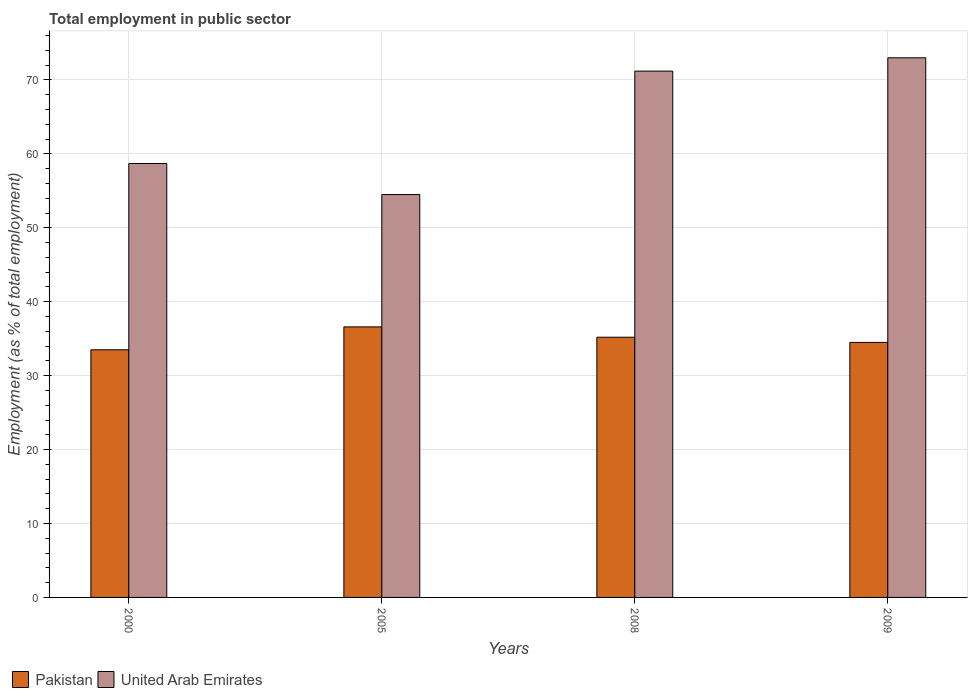Are the number of bars per tick equal to the number of legend labels?
Keep it short and to the point. Yes. Across all years, what is the maximum employment in public sector in United Arab Emirates?
Offer a terse response. 73. Across all years, what is the minimum employment in public sector in United Arab Emirates?
Ensure brevity in your answer.  54.5. What is the total employment in public sector in United Arab Emirates in the graph?
Your response must be concise. 257.4. What is the difference between the employment in public sector in Pakistan in 2000 and that in 2009?
Give a very brief answer. -1. What is the difference between the employment in public sector in Pakistan in 2000 and the employment in public sector in United Arab Emirates in 2005?
Give a very brief answer. -21. What is the average employment in public sector in Pakistan per year?
Your response must be concise. 34.95. In the year 2005, what is the difference between the employment in public sector in Pakistan and employment in public sector in United Arab Emirates?
Give a very brief answer. -17.9. In how many years, is the employment in public sector in United Arab Emirates greater than 54 %?
Make the answer very short. 4. What is the ratio of the employment in public sector in Pakistan in 2005 to that in 2009?
Ensure brevity in your answer.  1.06. Is the employment in public sector in Pakistan in 2000 less than that in 2008?
Keep it short and to the point. Yes. What is the difference between the highest and the second highest employment in public sector in Pakistan?
Offer a terse response. 1.4. What does the 2nd bar from the left in 2009 represents?
Offer a very short reply. United Arab Emirates. What does the 2nd bar from the right in 2005 represents?
Your answer should be very brief. Pakistan. Are all the bars in the graph horizontal?
Make the answer very short. No. Are the values on the major ticks of Y-axis written in scientific E-notation?
Your answer should be very brief. No. Does the graph contain any zero values?
Offer a very short reply. No. Does the graph contain grids?
Provide a short and direct response. Yes. Where does the legend appear in the graph?
Your response must be concise. Bottom left. How are the legend labels stacked?
Your response must be concise. Horizontal. What is the title of the graph?
Offer a terse response. Total employment in public sector. What is the label or title of the X-axis?
Ensure brevity in your answer.  Years. What is the label or title of the Y-axis?
Offer a very short reply. Employment (as % of total employment). What is the Employment (as % of total employment) in Pakistan in 2000?
Give a very brief answer. 33.5. What is the Employment (as % of total employment) in United Arab Emirates in 2000?
Make the answer very short. 58.7. What is the Employment (as % of total employment) of Pakistan in 2005?
Your answer should be compact. 36.6. What is the Employment (as % of total employment) in United Arab Emirates in 2005?
Your answer should be compact. 54.5. What is the Employment (as % of total employment) in Pakistan in 2008?
Your answer should be compact. 35.2. What is the Employment (as % of total employment) of United Arab Emirates in 2008?
Make the answer very short. 71.2. What is the Employment (as % of total employment) of Pakistan in 2009?
Make the answer very short. 34.5. What is the Employment (as % of total employment) of United Arab Emirates in 2009?
Ensure brevity in your answer.  73. Across all years, what is the maximum Employment (as % of total employment) of Pakistan?
Provide a succinct answer. 36.6. Across all years, what is the minimum Employment (as % of total employment) in Pakistan?
Ensure brevity in your answer.  33.5. Across all years, what is the minimum Employment (as % of total employment) of United Arab Emirates?
Keep it short and to the point. 54.5. What is the total Employment (as % of total employment) of Pakistan in the graph?
Provide a short and direct response. 139.8. What is the total Employment (as % of total employment) in United Arab Emirates in the graph?
Ensure brevity in your answer.  257.4. What is the difference between the Employment (as % of total employment) of Pakistan in 2000 and that in 2005?
Provide a succinct answer. -3.1. What is the difference between the Employment (as % of total employment) in Pakistan in 2000 and that in 2008?
Your response must be concise. -1.7. What is the difference between the Employment (as % of total employment) of United Arab Emirates in 2000 and that in 2008?
Your answer should be very brief. -12.5. What is the difference between the Employment (as % of total employment) in United Arab Emirates in 2000 and that in 2009?
Keep it short and to the point. -14.3. What is the difference between the Employment (as % of total employment) of Pakistan in 2005 and that in 2008?
Offer a very short reply. 1.4. What is the difference between the Employment (as % of total employment) of United Arab Emirates in 2005 and that in 2008?
Offer a terse response. -16.7. What is the difference between the Employment (as % of total employment) of United Arab Emirates in 2005 and that in 2009?
Offer a very short reply. -18.5. What is the difference between the Employment (as % of total employment) of Pakistan in 2008 and that in 2009?
Make the answer very short. 0.7. What is the difference between the Employment (as % of total employment) in Pakistan in 2000 and the Employment (as % of total employment) in United Arab Emirates in 2005?
Offer a terse response. -21. What is the difference between the Employment (as % of total employment) in Pakistan in 2000 and the Employment (as % of total employment) in United Arab Emirates in 2008?
Your answer should be very brief. -37.7. What is the difference between the Employment (as % of total employment) of Pakistan in 2000 and the Employment (as % of total employment) of United Arab Emirates in 2009?
Give a very brief answer. -39.5. What is the difference between the Employment (as % of total employment) in Pakistan in 2005 and the Employment (as % of total employment) in United Arab Emirates in 2008?
Your answer should be compact. -34.6. What is the difference between the Employment (as % of total employment) in Pakistan in 2005 and the Employment (as % of total employment) in United Arab Emirates in 2009?
Your answer should be very brief. -36.4. What is the difference between the Employment (as % of total employment) of Pakistan in 2008 and the Employment (as % of total employment) of United Arab Emirates in 2009?
Ensure brevity in your answer.  -37.8. What is the average Employment (as % of total employment) of Pakistan per year?
Your answer should be compact. 34.95. What is the average Employment (as % of total employment) in United Arab Emirates per year?
Give a very brief answer. 64.35. In the year 2000, what is the difference between the Employment (as % of total employment) of Pakistan and Employment (as % of total employment) of United Arab Emirates?
Ensure brevity in your answer.  -25.2. In the year 2005, what is the difference between the Employment (as % of total employment) of Pakistan and Employment (as % of total employment) of United Arab Emirates?
Provide a short and direct response. -17.9. In the year 2008, what is the difference between the Employment (as % of total employment) of Pakistan and Employment (as % of total employment) of United Arab Emirates?
Offer a very short reply. -36. In the year 2009, what is the difference between the Employment (as % of total employment) in Pakistan and Employment (as % of total employment) in United Arab Emirates?
Offer a very short reply. -38.5. What is the ratio of the Employment (as % of total employment) in Pakistan in 2000 to that in 2005?
Your answer should be compact. 0.92. What is the ratio of the Employment (as % of total employment) of United Arab Emirates in 2000 to that in 2005?
Give a very brief answer. 1.08. What is the ratio of the Employment (as % of total employment) in Pakistan in 2000 to that in 2008?
Your answer should be compact. 0.95. What is the ratio of the Employment (as % of total employment) in United Arab Emirates in 2000 to that in 2008?
Give a very brief answer. 0.82. What is the ratio of the Employment (as % of total employment) in United Arab Emirates in 2000 to that in 2009?
Offer a very short reply. 0.8. What is the ratio of the Employment (as % of total employment) in Pakistan in 2005 to that in 2008?
Offer a very short reply. 1.04. What is the ratio of the Employment (as % of total employment) in United Arab Emirates in 2005 to that in 2008?
Your answer should be compact. 0.77. What is the ratio of the Employment (as % of total employment) in Pakistan in 2005 to that in 2009?
Offer a terse response. 1.06. What is the ratio of the Employment (as % of total employment) of United Arab Emirates in 2005 to that in 2009?
Keep it short and to the point. 0.75. What is the ratio of the Employment (as % of total employment) of Pakistan in 2008 to that in 2009?
Make the answer very short. 1.02. What is the ratio of the Employment (as % of total employment) in United Arab Emirates in 2008 to that in 2009?
Offer a terse response. 0.98. What is the difference between the highest and the second highest Employment (as % of total employment) in United Arab Emirates?
Provide a succinct answer. 1.8. What is the difference between the highest and the lowest Employment (as % of total employment) in Pakistan?
Offer a very short reply. 3.1. 